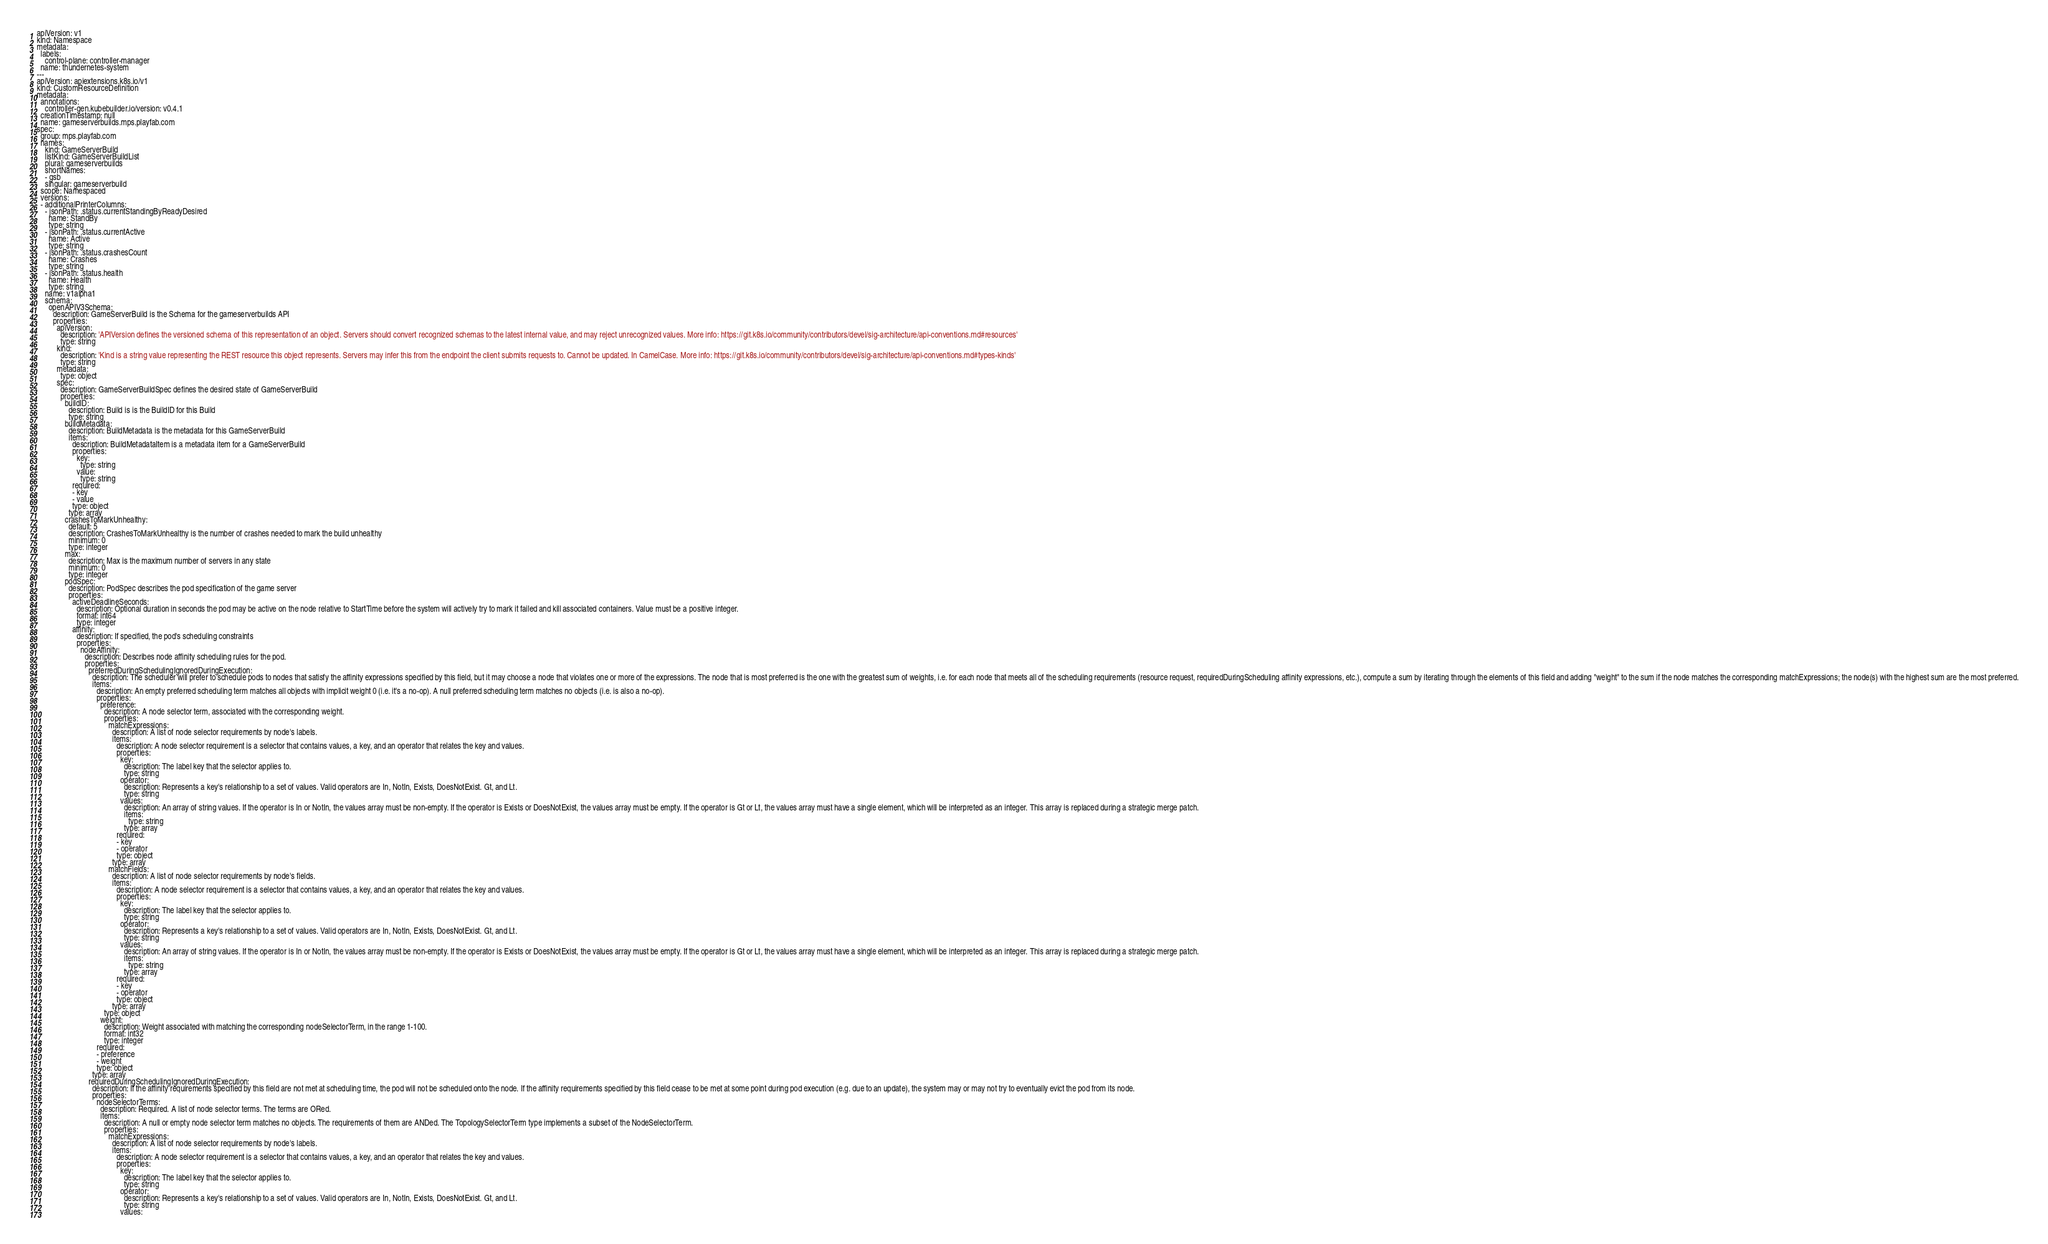Convert code to text. <code><loc_0><loc_0><loc_500><loc_500><_YAML_>apiVersion: v1
kind: Namespace
metadata:
  labels:
    control-plane: controller-manager
  name: thundernetes-system
---
apiVersion: apiextensions.k8s.io/v1
kind: CustomResourceDefinition
metadata:
  annotations:
    controller-gen.kubebuilder.io/version: v0.4.1
  creationTimestamp: null
  name: gameserverbuilds.mps.playfab.com
spec:
  group: mps.playfab.com
  names:
    kind: GameServerBuild
    listKind: GameServerBuildList
    plural: gameserverbuilds
    shortNames:
    - gsb
    singular: gameserverbuild
  scope: Namespaced
  versions:
  - additionalPrinterColumns:
    - jsonPath: .status.currentStandingByReadyDesired
      name: StandBy
      type: string
    - jsonPath: .status.currentActive
      name: Active
      type: string
    - jsonPath: .status.crashesCount
      name: Crashes
      type: string
    - jsonPath: .status.health
      name: Health
      type: string
    name: v1alpha1
    schema:
      openAPIV3Schema:
        description: GameServerBuild is the Schema for the gameserverbuilds API
        properties:
          apiVersion:
            description: 'APIVersion defines the versioned schema of this representation of an object. Servers should convert recognized schemas to the latest internal value, and may reject unrecognized values. More info: https://git.k8s.io/community/contributors/devel/sig-architecture/api-conventions.md#resources'
            type: string
          kind:
            description: 'Kind is a string value representing the REST resource this object represents. Servers may infer this from the endpoint the client submits requests to. Cannot be updated. In CamelCase. More info: https://git.k8s.io/community/contributors/devel/sig-architecture/api-conventions.md#types-kinds'
            type: string
          metadata:
            type: object
          spec:
            description: GameServerBuildSpec defines the desired state of GameServerBuild
            properties:
              buildID:
                description: Build is is the BuildID for this Build
                type: string
              buildMetadata:
                description: BuildMetadata is the metadata for this GameServerBuild
                items:
                  description: BuildMetadataItem is a metadata item for a GameServerBuild
                  properties:
                    key:
                      type: string
                    value:
                      type: string
                  required:
                  - key
                  - value
                  type: object
                type: array
              crashesToMarkUnhealthy:
                default: 5
                description: CrashesToMarkUnhealthy is the number of crashes needed to mark the build unhealthy
                minimum: 0
                type: integer
              max:
                description: Max is the maximum number of servers in any state
                minimum: 0
                type: integer
              podSpec:
                description: PodSpec describes the pod specification of the game server
                properties:
                  activeDeadlineSeconds:
                    description: Optional duration in seconds the pod may be active on the node relative to StartTime before the system will actively try to mark it failed and kill associated containers. Value must be a positive integer.
                    format: int64
                    type: integer
                  affinity:
                    description: If specified, the pod's scheduling constraints
                    properties:
                      nodeAffinity:
                        description: Describes node affinity scheduling rules for the pod.
                        properties:
                          preferredDuringSchedulingIgnoredDuringExecution:
                            description: The scheduler will prefer to schedule pods to nodes that satisfy the affinity expressions specified by this field, but it may choose a node that violates one or more of the expressions. The node that is most preferred is the one with the greatest sum of weights, i.e. for each node that meets all of the scheduling requirements (resource request, requiredDuringScheduling affinity expressions, etc.), compute a sum by iterating through the elements of this field and adding "weight" to the sum if the node matches the corresponding matchExpressions; the node(s) with the highest sum are the most preferred.
                            items:
                              description: An empty preferred scheduling term matches all objects with implicit weight 0 (i.e. it's a no-op). A null preferred scheduling term matches no objects (i.e. is also a no-op).
                              properties:
                                preference:
                                  description: A node selector term, associated with the corresponding weight.
                                  properties:
                                    matchExpressions:
                                      description: A list of node selector requirements by node's labels.
                                      items:
                                        description: A node selector requirement is a selector that contains values, a key, and an operator that relates the key and values.
                                        properties:
                                          key:
                                            description: The label key that the selector applies to.
                                            type: string
                                          operator:
                                            description: Represents a key's relationship to a set of values. Valid operators are In, NotIn, Exists, DoesNotExist. Gt, and Lt.
                                            type: string
                                          values:
                                            description: An array of string values. If the operator is In or NotIn, the values array must be non-empty. If the operator is Exists or DoesNotExist, the values array must be empty. If the operator is Gt or Lt, the values array must have a single element, which will be interpreted as an integer. This array is replaced during a strategic merge patch.
                                            items:
                                              type: string
                                            type: array
                                        required:
                                        - key
                                        - operator
                                        type: object
                                      type: array
                                    matchFields:
                                      description: A list of node selector requirements by node's fields.
                                      items:
                                        description: A node selector requirement is a selector that contains values, a key, and an operator that relates the key and values.
                                        properties:
                                          key:
                                            description: The label key that the selector applies to.
                                            type: string
                                          operator:
                                            description: Represents a key's relationship to a set of values. Valid operators are In, NotIn, Exists, DoesNotExist. Gt, and Lt.
                                            type: string
                                          values:
                                            description: An array of string values. If the operator is In or NotIn, the values array must be non-empty. If the operator is Exists or DoesNotExist, the values array must be empty. If the operator is Gt or Lt, the values array must have a single element, which will be interpreted as an integer. This array is replaced during a strategic merge patch.
                                            items:
                                              type: string
                                            type: array
                                        required:
                                        - key
                                        - operator
                                        type: object
                                      type: array
                                  type: object
                                weight:
                                  description: Weight associated with matching the corresponding nodeSelectorTerm, in the range 1-100.
                                  format: int32
                                  type: integer
                              required:
                              - preference
                              - weight
                              type: object
                            type: array
                          requiredDuringSchedulingIgnoredDuringExecution:
                            description: If the affinity requirements specified by this field are not met at scheduling time, the pod will not be scheduled onto the node. If the affinity requirements specified by this field cease to be met at some point during pod execution (e.g. due to an update), the system may or may not try to eventually evict the pod from its node.
                            properties:
                              nodeSelectorTerms:
                                description: Required. A list of node selector terms. The terms are ORed.
                                items:
                                  description: A null or empty node selector term matches no objects. The requirements of them are ANDed. The TopologySelectorTerm type implements a subset of the NodeSelectorTerm.
                                  properties:
                                    matchExpressions:
                                      description: A list of node selector requirements by node's labels.
                                      items:
                                        description: A node selector requirement is a selector that contains values, a key, and an operator that relates the key and values.
                                        properties:
                                          key:
                                            description: The label key that the selector applies to.
                                            type: string
                                          operator:
                                            description: Represents a key's relationship to a set of values. Valid operators are In, NotIn, Exists, DoesNotExist. Gt, and Lt.
                                            type: string
                                          values:</code> 